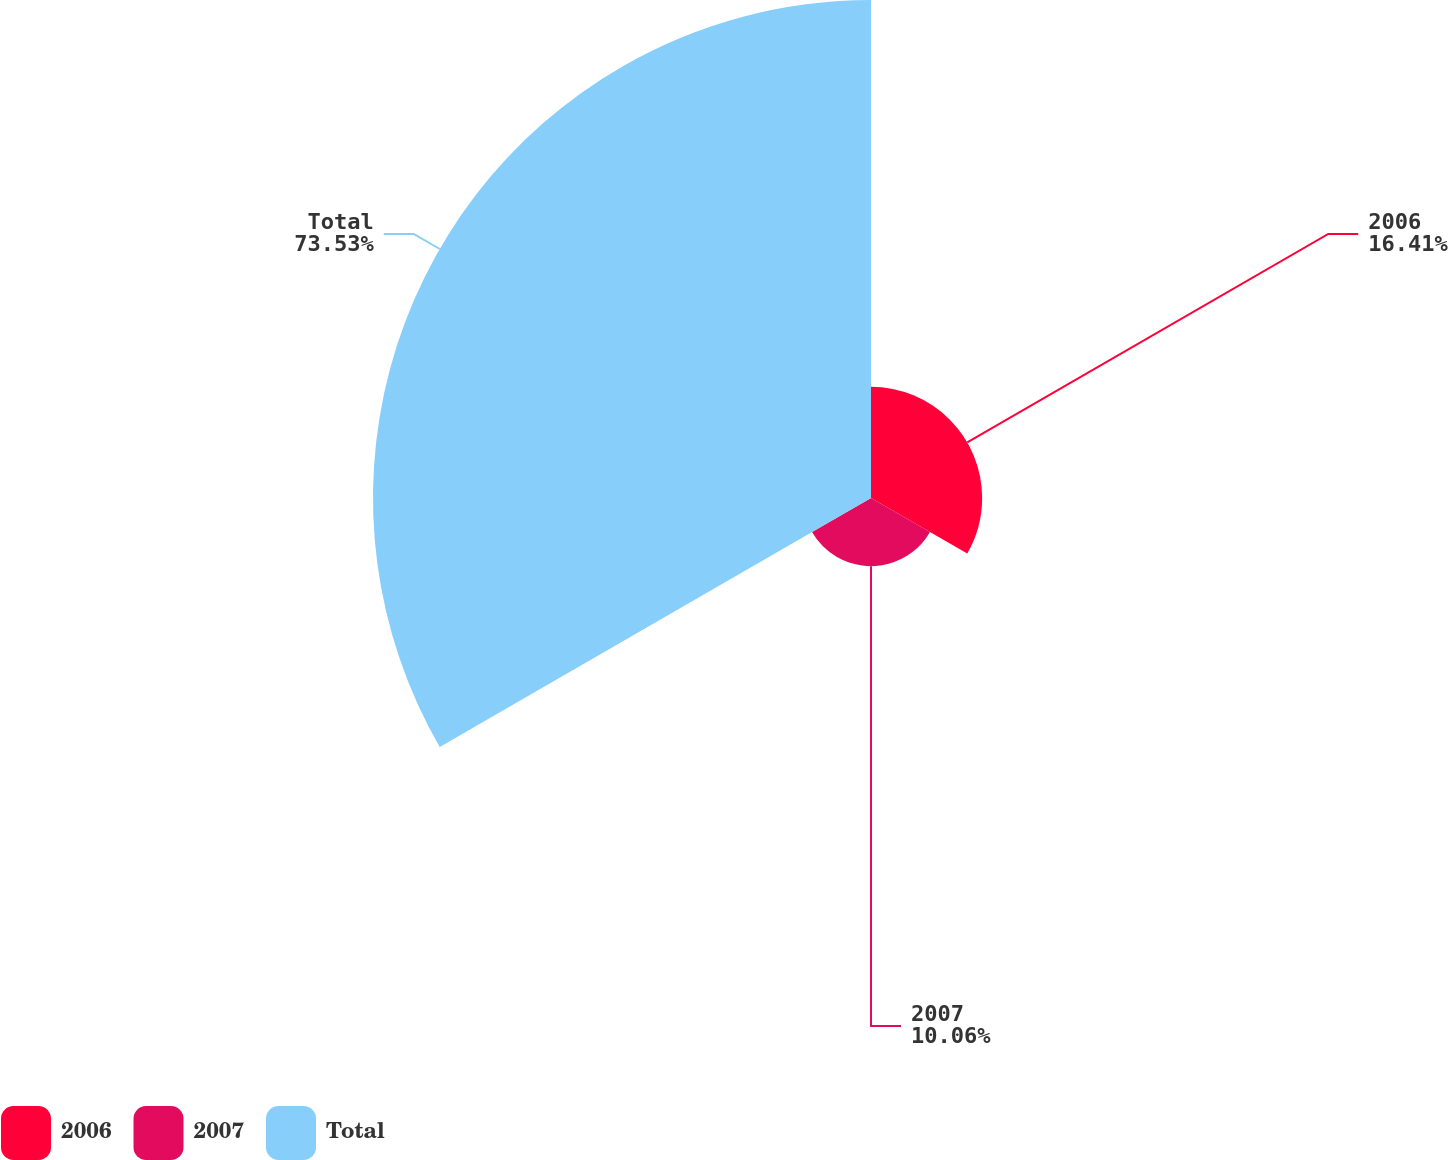Convert chart to OTSL. <chart><loc_0><loc_0><loc_500><loc_500><pie_chart><fcel>2006<fcel>2007<fcel>Total<nl><fcel>16.41%<fcel>10.06%<fcel>73.53%<nl></chart> 